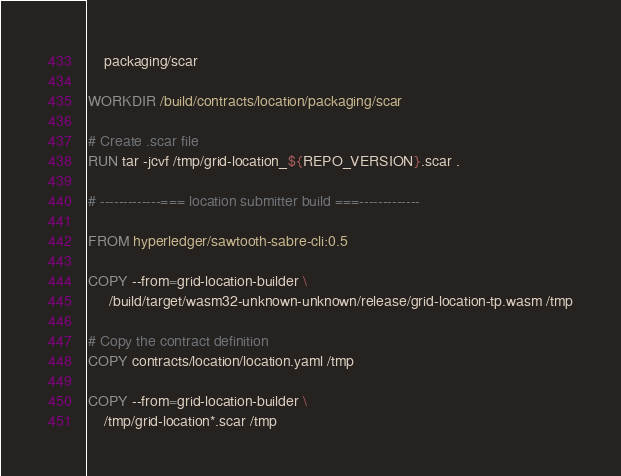<code> <loc_0><loc_0><loc_500><loc_500><_Dockerfile_>    packaging/scar

WORKDIR /build/contracts/location/packaging/scar

# Create .scar file
RUN tar -jcvf /tmp/grid-location_${REPO_VERSION}.scar .

# -------------=== location submitter build ===-------------

FROM hyperledger/sawtooth-sabre-cli:0.5

COPY --from=grid-location-builder \
     /build/target/wasm32-unknown-unknown/release/grid-location-tp.wasm /tmp

# Copy the contract definition
COPY contracts/location/location.yaml /tmp

COPY --from=grid-location-builder \
    /tmp/grid-location*.scar /tmp
</code> 